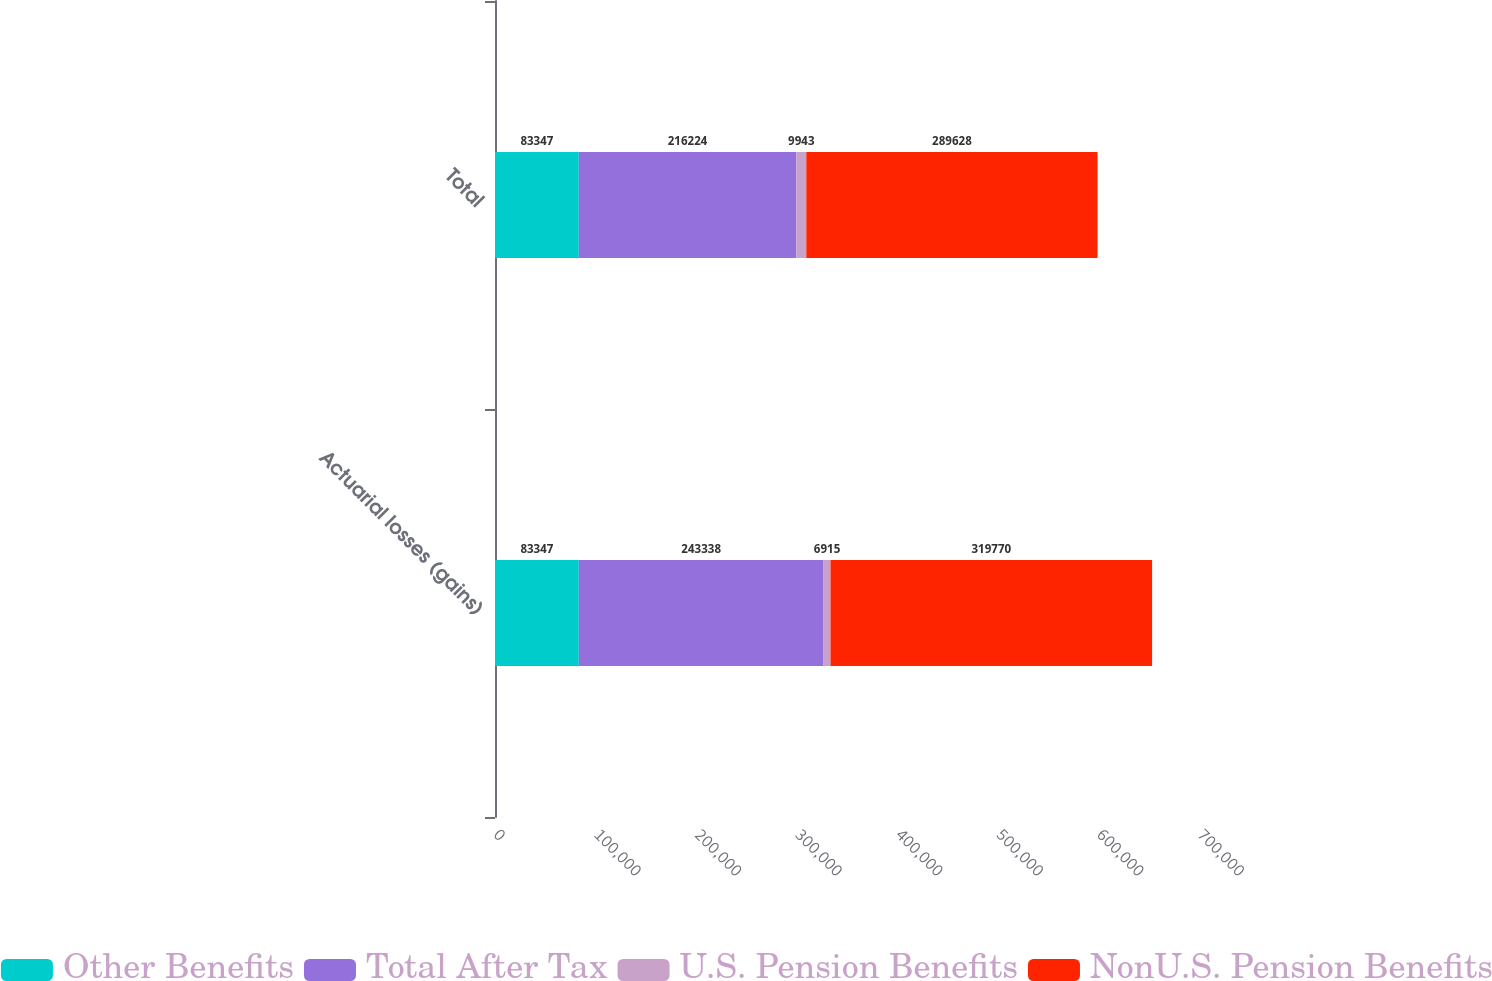Convert chart. <chart><loc_0><loc_0><loc_500><loc_500><stacked_bar_chart><ecel><fcel>Actuarial losses (gains)<fcel>Total<nl><fcel>Other Benefits<fcel>83347<fcel>83347<nl><fcel>Total After Tax<fcel>243338<fcel>216224<nl><fcel>U.S. Pension Benefits<fcel>6915<fcel>9943<nl><fcel>NonU.S. Pension Benefits<fcel>319770<fcel>289628<nl></chart> 